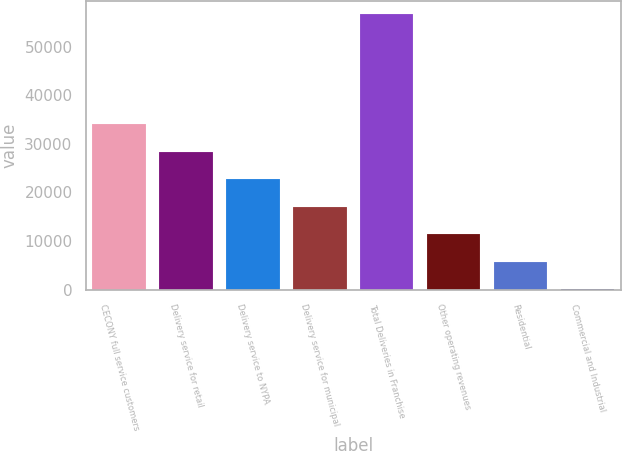Convert chart to OTSL. <chart><loc_0><loc_0><loc_500><loc_500><bar_chart><fcel>CECONY full service customers<fcel>Delivery service for retail<fcel>Delivery service to NYPA<fcel>Delivery service for municipal<fcel>Total Deliveries in Franchise<fcel>Other operating revenues<fcel>Residential<fcel>Commercial and Industrial<nl><fcel>34008<fcel>28343.3<fcel>22678.6<fcel>17013.8<fcel>56667<fcel>11349.1<fcel>5684.34<fcel>19.6<nl></chart> 